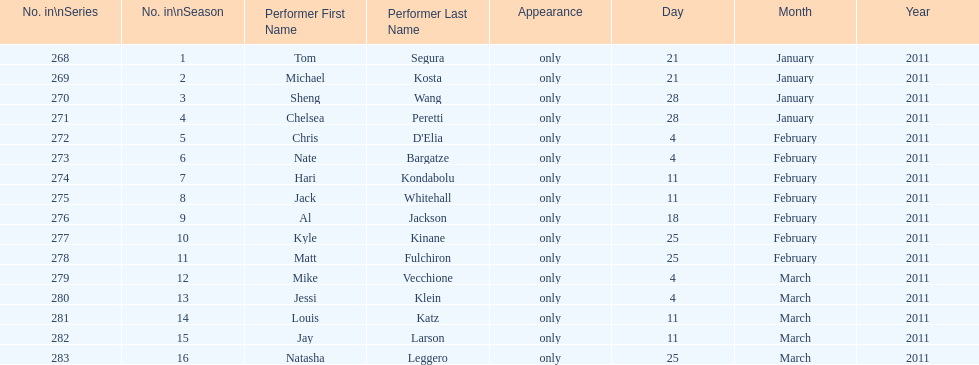Did al jackson air before or after kyle kinane? Before. 